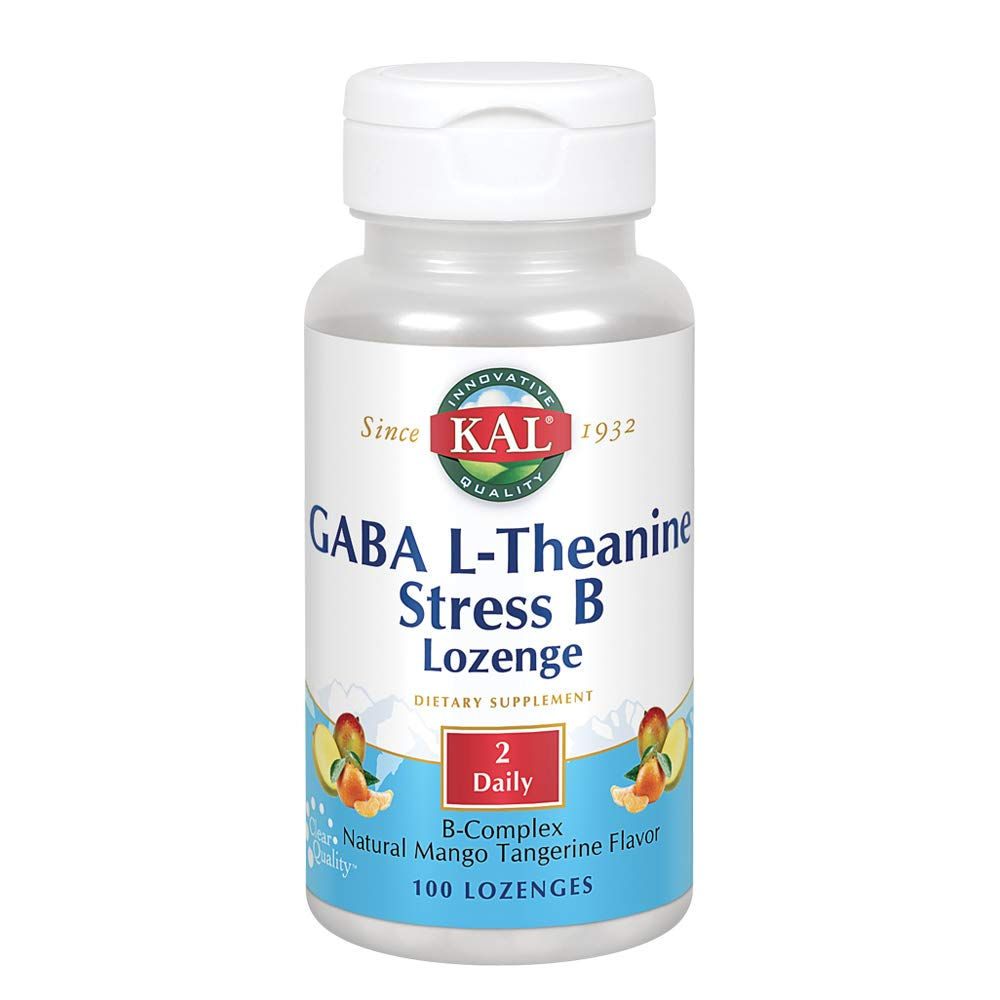What creative ways can someone incorporate this supplement into their daily routine? One creative way to incorporate this supplement into a daily routine could be to pair it with a relaxation ritual. For instance, someone could set aside a few minutes in the evening to unwind with a cup of herbal tea while taking the lozenge. This would create a moment of calm and reinforce the habit of taking the supplement. Alternatively, integrating the supplement into a morning meditation or stretching routine can provide a structured and mindful start to the day while ensuring the lozenge is consumed. How might someone ensure they never miss a dose of this supplement? To ensure they never miss a dose, a person can set digital reminders on their phone or use a pill organizer with a designated slot for each day's lozenge. They could also tie the habit to an existing routine, such as taking it right after brushing their teeth in the morning or before bed. Additionally, keeping a supply in multiple locations, such as at home and at work, can help ensure they have access no matter where they are. Imagine a wild scenario where taking this supplement transforms someone's day in a surprising way. Imagine a scenario where a person takes this supplement in the morning, and its stress-relief properties are so effective that they find themselves in an incredibly zen state. As they walk to work, they calmly navigate through a bustling crowd, helping a lost tourist find their way with a smile. At the office, their serenity becomes contagious, raising everyone's spirits and productivity. They end the day with an innovative idea that not only earns them praise but also sets a new direction for their company. This transformation from one lozenge leads to unexpected waves of positivity and productivity! 